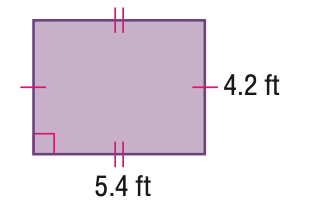Answer the mathemtical geometry problem and directly provide the correct option letter.
Question: Find the area of the parallelogram. Round to the nearest tenth if necessary.
Choices: A: 17.6 B: 19.2 C: 22.7 D: 29.2 C 